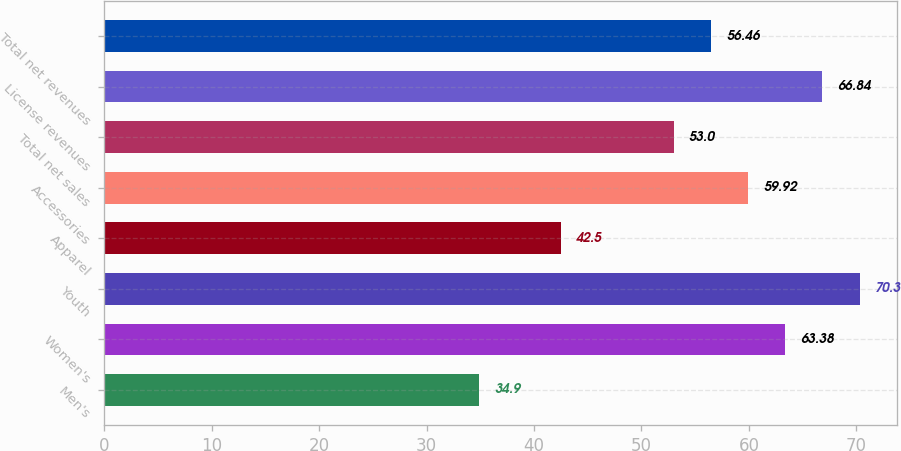<chart> <loc_0><loc_0><loc_500><loc_500><bar_chart><fcel>Men's<fcel>Women's<fcel>Youth<fcel>Apparel<fcel>Accessories<fcel>Total net sales<fcel>License revenues<fcel>Total net revenues<nl><fcel>34.9<fcel>63.38<fcel>70.3<fcel>42.5<fcel>59.92<fcel>53<fcel>66.84<fcel>56.46<nl></chart> 